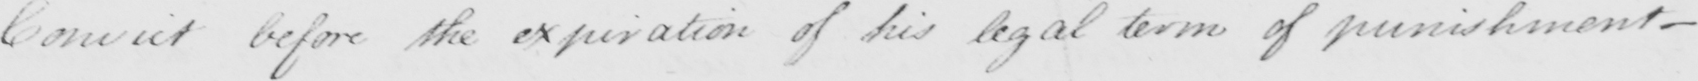Please provide the text content of this handwritten line. Convict before the expiration of his legal terms of punishment_ 